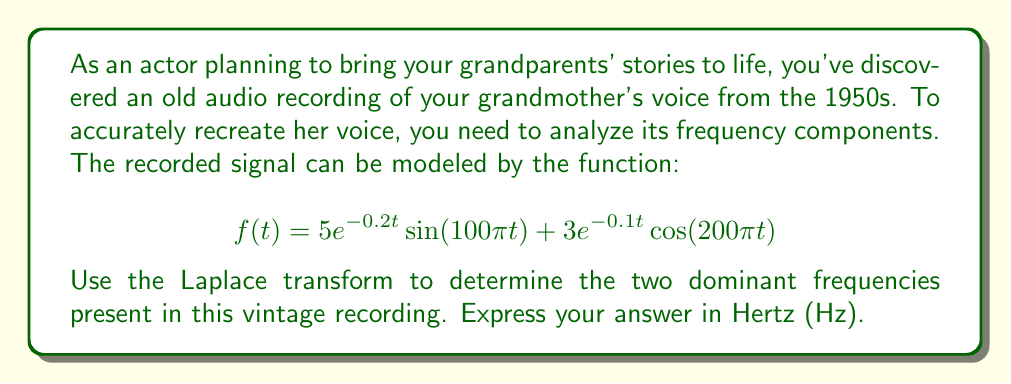Provide a solution to this math problem. To solve this problem, we'll follow these steps:

1) First, let's recall the Laplace transform of sine and cosine functions:
   
   $$\mathcal{L}\{e^{at}\sin(bt)\} = \frac{b}{(s-a)^2 + b^2}$$
   $$\mathcal{L}\{e^{at}\cos(bt)\} = \frac{s-a}{(s-a)^2 + b^2}$$

2) Now, let's apply the Laplace transform to our function:

   $$\mathcal{L}\{f(t)\} = 5\mathcal{L}\{e^{-0.2t}\sin(100\pi t)\} + 3\mathcal{L}\{e^{-0.1t}\cos(200\pi t)\}$$

3) Using the formulas from step 1:

   $$\mathcal{L}\{f(t)\} = 5\frac{100\pi}{(s+0.2)^2 + (100\pi)^2} + 3\frac{s+0.1}{(s+0.1)^2 + (200\pi)^2}$$

4) The denominator of each term represents the characteristic equation of the system. The imaginary parts of the roots of these equations give us the frequencies.

5) For the first term: $(s+0.2)^2 + (100\pi)^2 = 0$
   Solving this: $s = -0.2 \pm 100\pi i$

6) For the second term: $(s+0.1)^2 + (200\pi)^2 = 0$
   Solving this: $s = -0.1 \pm 200\pi i$

7) The imaginary parts (100π and 200π) represent the angular frequencies in radians per second. To convert to Hz, we divide by 2π:

   $f_1 = \frac{100\pi}{2\pi} = 50$ Hz
   $f_2 = \frac{200\pi}{2\pi} = 100$ Hz

Therefore, the two dominant frequencies in the recording are 50 Hz and 100 Hz.
Answer: The two dominant frequencies in the vintage audio recording are 50 Hz and 100 Hz. 